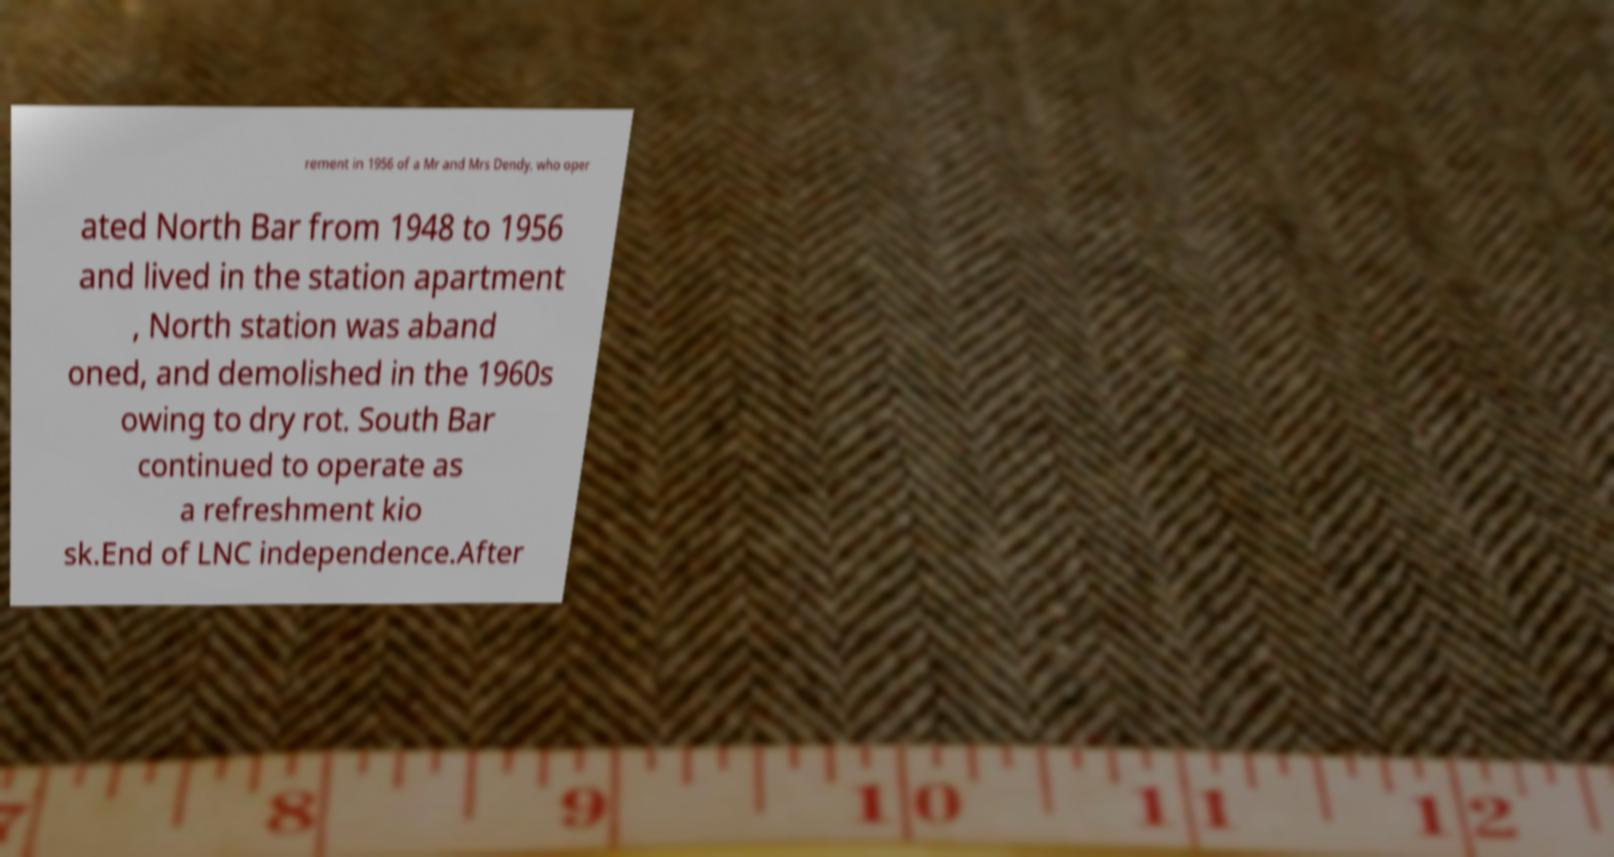Can you accurately transcribe the text from the provided image for me? rement in 1956 of a Mr and Mrs Dendy, who oper ated North Bar from 1948 to 1956 and lived in the station apartment , North station was aband oned, and demolished in the 1960s owing to dry rot. South Bar continued to operate as a refreshment kio sk.End of LNC independence.After 